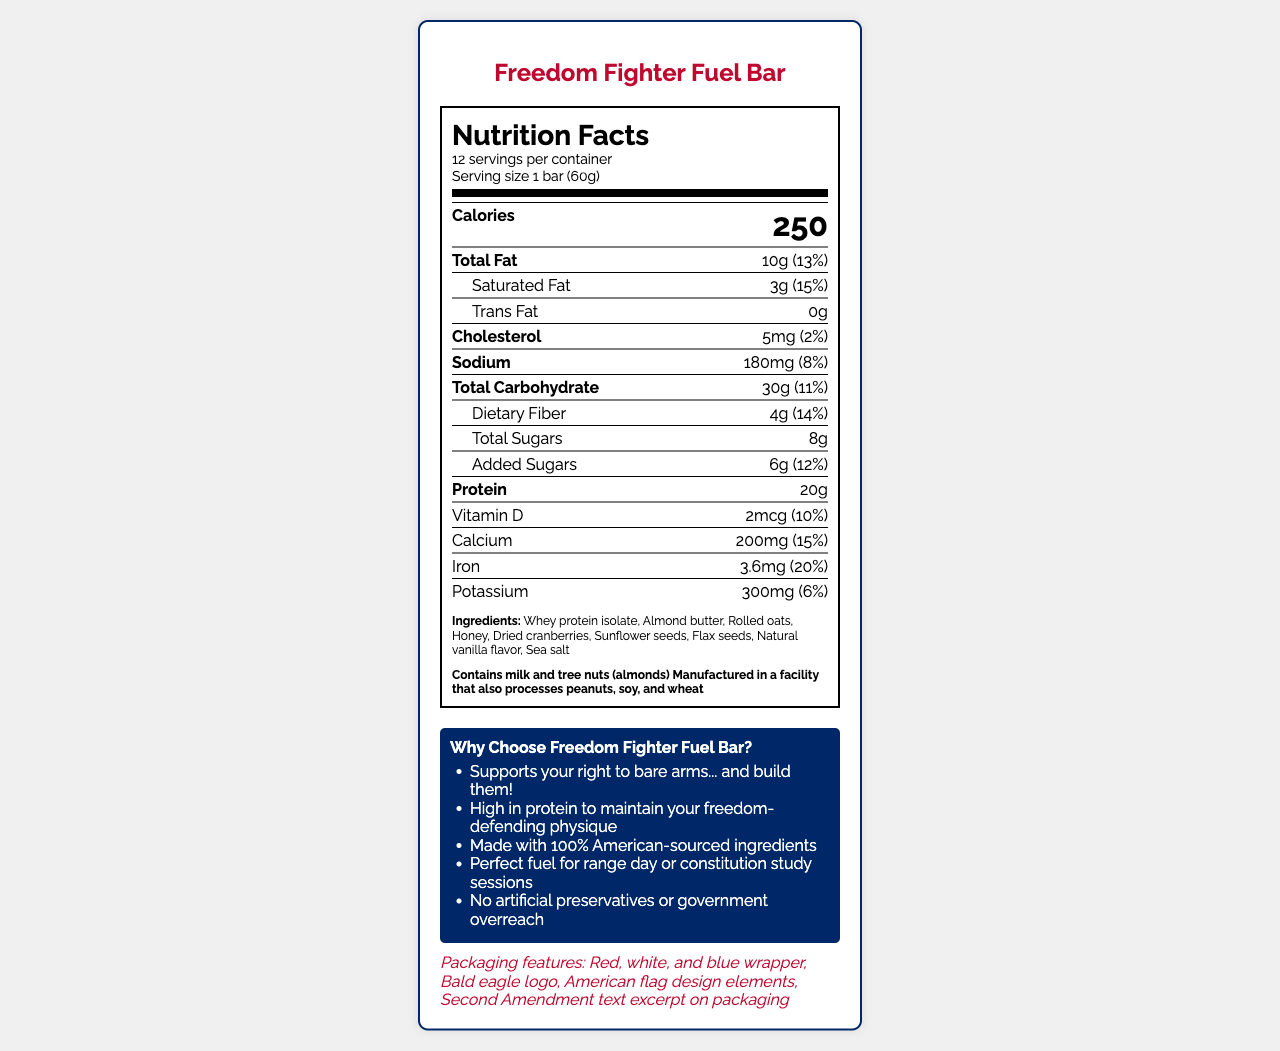what is the serving size of the Freedom Fighter Fuel Bar? The serving size is clearly listed as "1 bar (60g)" in the nutrition label section.
Answer: 1 bar (60g) how many servings are there in a container? The document states that there are 12 servings per container.
Answer: 12 what is the total fat amount per serving? The nutrition label lists the total fat amount as 10g.
Answer: 10g how much protein does each bar contain? The protein content is listed as 20g on the nutrition label.
Answer: 20g which ingredients are used in the Freedom Fighter Fuel Bar? The ingredients section lists all these items.
Answer: Whey protein isolate, Almond butter, Rolled oats, Honey, Dried cranberries, Sunflower seeds, Flax seeds, Natural vanilla flavor, Sea salt how many calories are in one bar? The document lists the calorie content per bar as 250.
Answer: 250 what is the amount of dietary fiber in each bar? A. 2g B. 3g C. 4g D. 5g The dietary fiber content per bar is listed as 4g.
Answer: C which allergen is not mentioned in the document? A. Milk B. Tree nuts C. Fish D. Wheat The allergens listed include milk, tree nuts, peanuts, soy, and wheat, but not fish.
Answer: C does the Freedom Fighter Fuel Bar contain any trans fat? The document states that the trans fat content is 0g.
Answer: No is the sodium content in each bar less than 200mg? The sodium content is listed as 180mg, which is less than 200mg.
Answer: Yes summarize the nutritional highlights and features of the Freedom Fighter Fuel Bar. The document describes the product as having a variety of nutrients and natural ingredients, being high in protein, and targeting an audience that values their right to bear arms. The packaging and marketing claims emphasize patriotism and freedom.
Answer: A patriotic-themed, high-protein nutrition bar designed for Second Amendment supporters, the Freedom Fighter Fuel Bar contains 250 calories per serving with significant protein (20g) and total fat (10g). The bar includes a mix of natural ingredients such as whey protein isolate, almond butter, and honey, with no artificial preservatives. Its packaging features patriotic designs and marketing claims that appeal to its target audience. what is the daily value percentage for calcium per bar? The daily value percentage for calcium is listed as 15%.
Answer: 15% how much added sugar is there per serving, and what is its daily value percentage? The document lists the added sugars as 6g per serving, which is 12% of the daily value.
Answer: 6g, 12% is there any iron in the Freedom Fighter Fuel Bar? The document lists iron content as 3.6mg, which is 20% of the daily value.
Answer: Yes the facility where the bar is manufactured also processes which allergens? The allergens section states that the facility also processes peanuts, soy, and wheat.
Answer: Peanuts, soy, and wheat what are the features of the patriotic packaging? The document lists these specific features under the patriotic packaging section.
Answer: Red, white, and blue wrapper, Bald eagle logo, American flag design elements, Second Amendment text excerpt can you determine where the ingredients are sourced from? The document claims the ingredients are 100% American-sourced, but it doesn't provide specific sourcing details, so this cannot be verified solely based on the visual information in the document.
Answer: No 